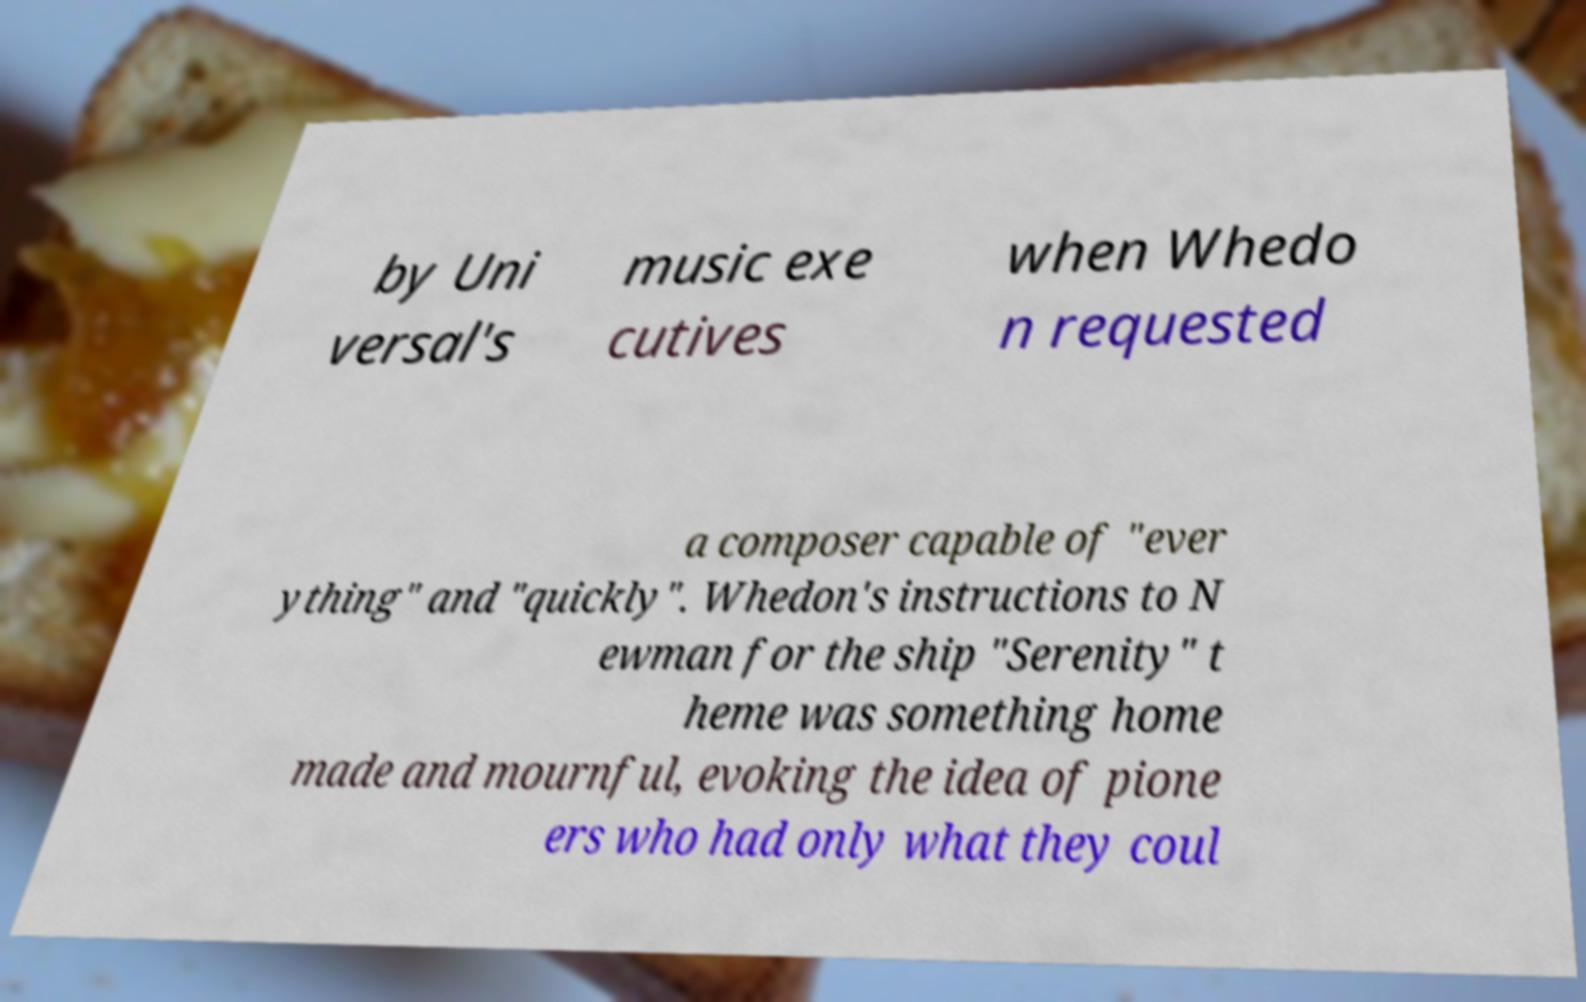Could you assist in decoding the text presented in this image and type it out clearly? by Uni versal's music exe cutives when Whedo n requested a composer capable of "ever ything" and "quickly". Whedon's instructions to N ewman for the ship "Serenity" t heme was something home made and mournful, evoking the idea of pione ers who had only what they coul 